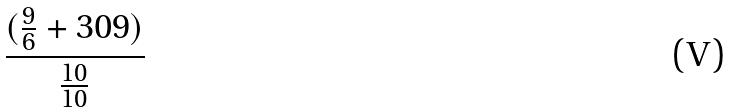<formula> <loc_0><loc_0><loc_500><loc_500>\frac { ( \frac { 9 } { 6 } + 3 0 9 ) } { \frac { 1 0 } { 1 0 } }</formula> 